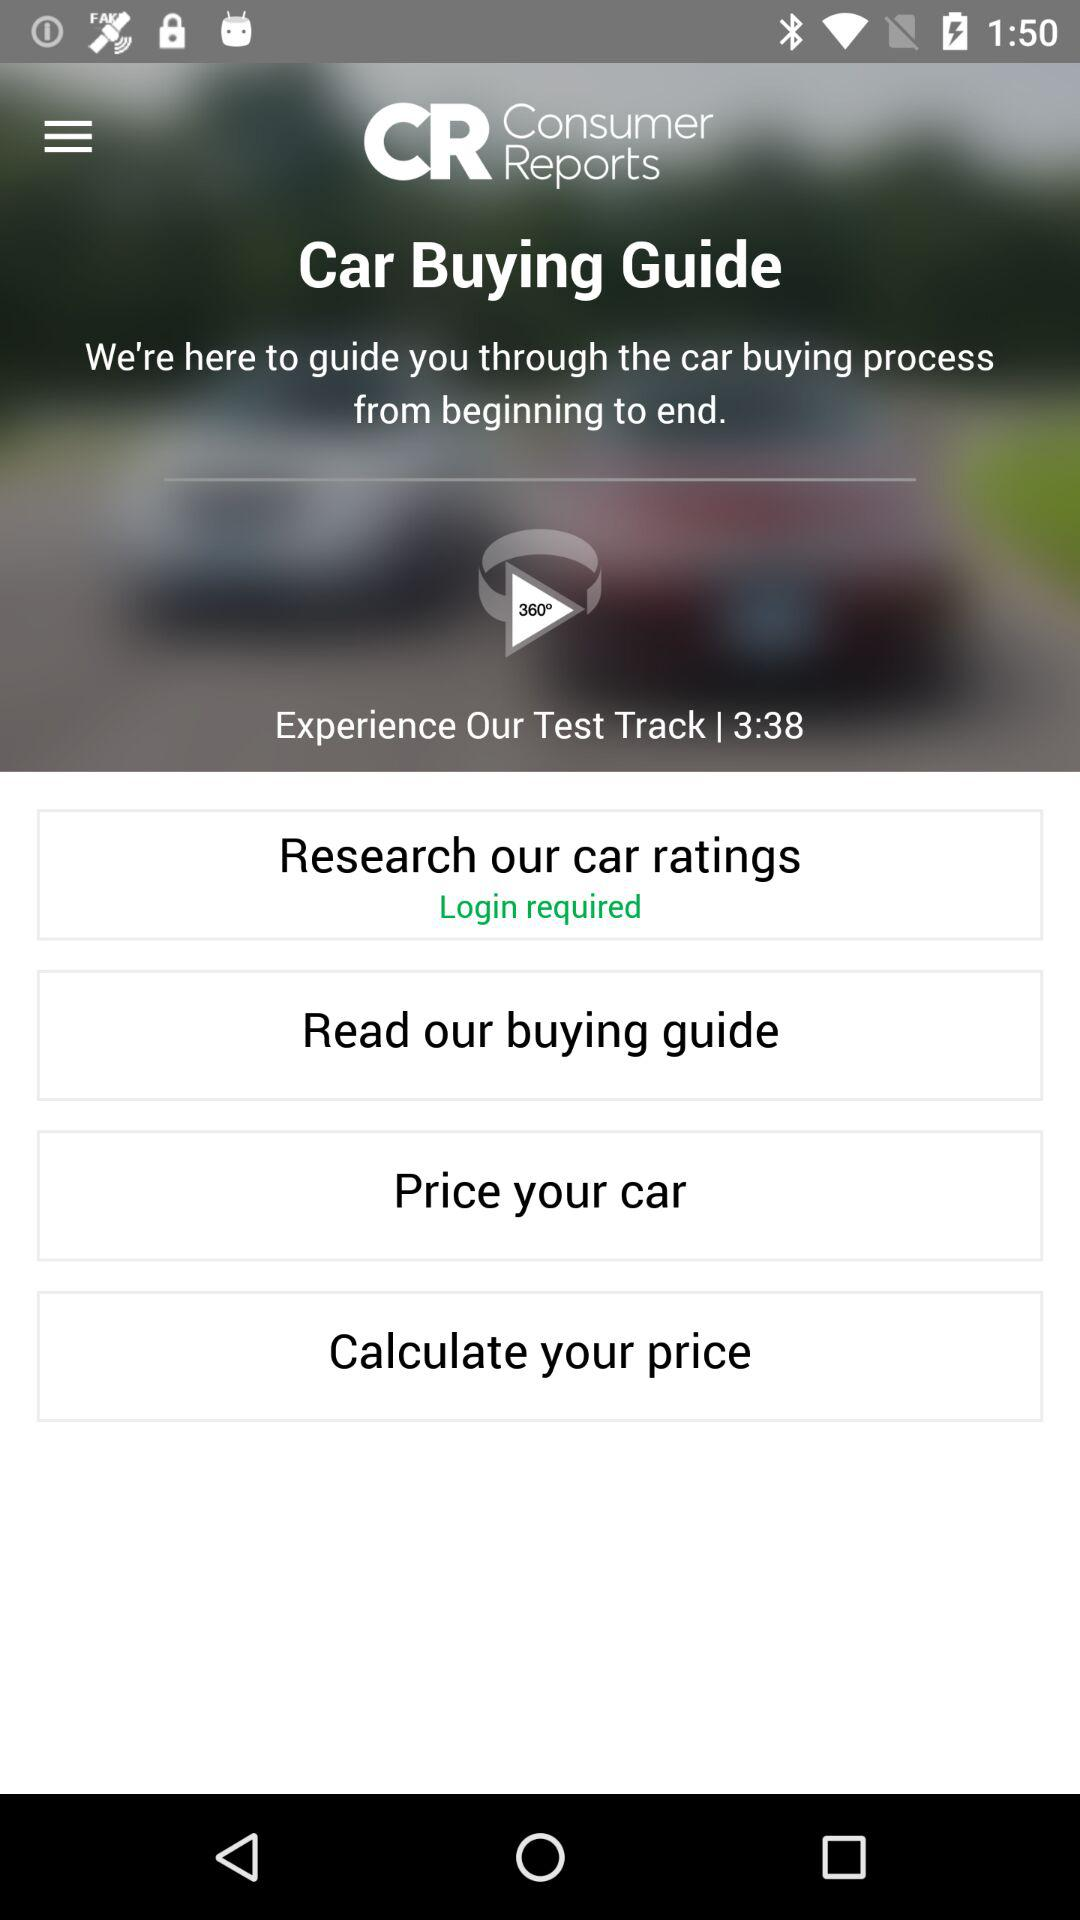What is the duration of the test track? The duration is 3 minutes and 38 seconds. 